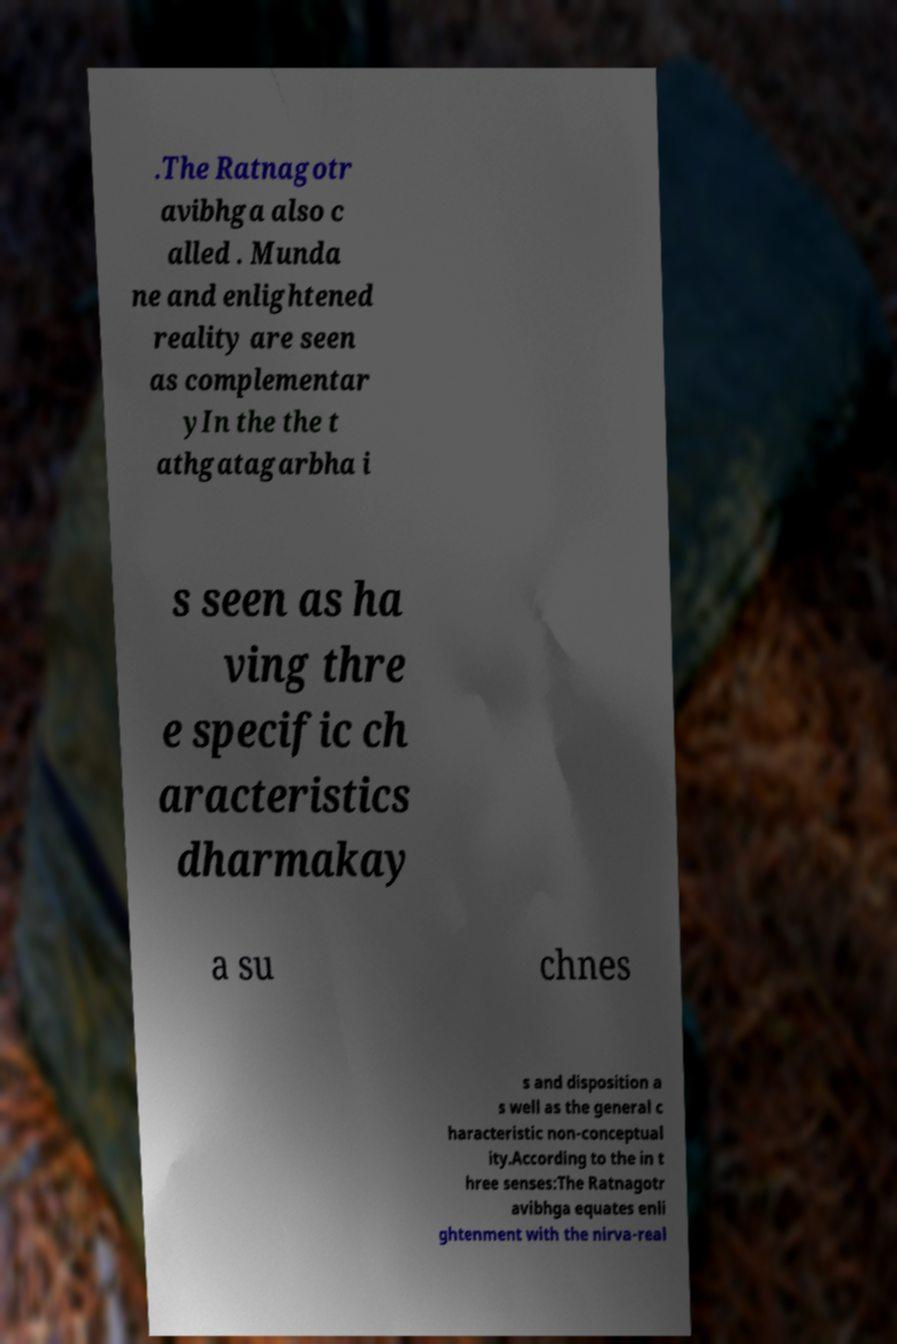For documentation purposes, I need the text within this image transcribed. Could you provide that? .The Ratnagotr avibhga also c alled . Munda ne and enlightened reality are seen as complementar yIn the the t athgatagarbha i s seen as ha ving thre e specific ch aracteristics dharmakay a su chnes s and disposition a s well as the general c haracteristic non-conceptual ity.According to the in t hree senses:The Ratnagotr avibhga equates enli ghtenment with the nirva-real 